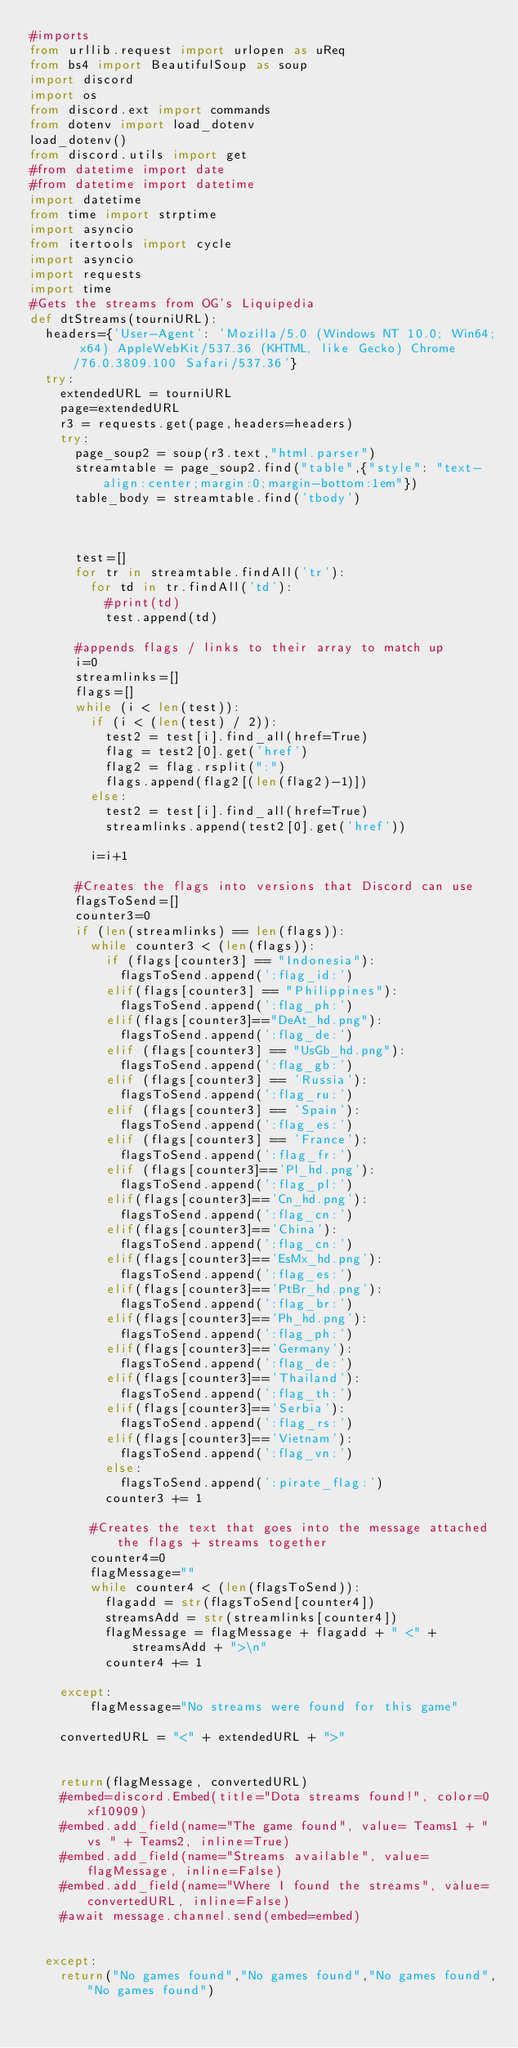<code> <loc_0><loc_0><loc_500><loc_500><_Python_>#imports
from urllib.request import urlopen as uReq
from bs4 import BeautifulSoup as soup
import discord
import os
from discord.ext import commands
from dotenv import load_dotenv
load_dotenv()
from discord.utils import get
#from datetime import date
#from datetime import datetime
import datetime
from time import strptime
import asyncio
from itertools import cycle
import asyncio
import requests
import time
#Gets the streams from OG's Liquipedia
def dtStreams(tourniURL):
  headers={'User-Agent': 'Mozilla/5.0 (Windows NT 10.0; Win64; x64) AppleWebKit/537.36 (KHTML, like Gecko) Chrome/76.0.3809.100 Safari/537.36'}
  try:
    extendedURL = tourniURL
    page=extendedURL
    r3 = requests.get(page,headers=headers)
    try:
      page_soup2 = soup(r3.text,"html.parser")
      streamtable = page_soup2.find("table",{"style": "text-align:center;margin:0;margin-bottom:1em"})
      table_body = streamtable.find('tbody')
      


      test=[]
      for tr in streamtable.findAll('tr'):
        for td in tr.findAll('td'):
          #print(td)
          test.append(td)
          
      #appends flags / links to their array to match up
      i=0
      streamlinks=[]
      flags=[]
      while (i < len(test)):
        if (i < (len(test) / 2)):
          test2 = test[i].find_all(href=True)
          flag = test2[0].get('href')
          flag2 = flag.rsplit(":")
          flags.append(flag2[(len(flag2)-1)])
        else:
          test2 = test[i].find_all(href=True)
          streamlinks.append(test2[0].get('href'))
        
        i=i+1
      
      #Creates the flags into versions that Discord can use
      flagsToSend=[]
      counter3=0
      if (len(streamlinks) == len(flags)):
        while counter3 < (len(flags)):
          if (flags[counter3] == "Indonesia"):
            flagsToSend.append(':flag_id:')
          elif(flags[counter3] == "Philippines"):
            flagsToSend.append(':flag_ph:')
          elif(flags[counter3]=="DeAt_hd.png"):
            flagsToSend.append(':flag_de:')
          elif (flags[counter3] == "UsGb_hd.png"):
            flagsToSend.append(':flag_gb:')
          elif (flags[counter3] == 'Russia'):
            flagsToSend.append(':flag_ru:')
          elif (flags[counter3] == 'Spain'):
            flagsToSend.append(':flag_es:')
          elif (flags[counter3] == 'France'):
            flagsToSend.append(':flag_fr:')
          elif (flags[counter3]=='Pl_hd.png'):
            flagsToSend.append(':flag_pl:')
          elif(flags[counter3]=='Cn_hd.png'):
            flagsToSend.append(':flag_cn:')
          elif(flags[counter3]=='China'):
            flagsToSend.append(':flag_cn:')
          elif(flags[counter3]=='EsMx_hd.png'):
            flagsToSend.append(':flag_es:')
          elif(flags[counter3]=='PtBr_hd.png'):
            flagsToSend.append(':flag_br:')
          elif(flags[counter3]=='Ph_hd.png'):
            flagsToSend.append(':flag_ph:')
          elif(flags[counter3]=='Germany'):
            flagsToSend.append(':flag_de:')
          elif(flags[counter3]=='Thailand'):
            flagsToSend.append(':flag_th:')
          elif(flags[counter3]=='Serbia'):
            flagsToSend.append(':flag_rs:')
          elif(flags[counter3]=='Vietnam'):
            flagsToSend.append(':flag_vn:')
          else:
            flagsToSend.append(':pirate_flag:')
          counter3 += 1

        #Creates the text that goes into the message attached the flags + streams together 
        counter4=0
        flagMessage=""
        while counter4 < (len(flagsToSend)):
          flagadd = str(flagsToSend[counter4])
          streamsAdd = str(streamlinks[counter4])
          flagMessage = flagMessage + flagadd + " <" + streamsAdd + ">\n"
          counter4 += 1  

    except:
        flagMessage="No streams were found for this game"
      
    convertedURL = "<" + extendedURL + ">"


    return(flagMessage, convertedURL)
    #embed=discord.Embed(title="Dota streams found!", color=0xf10909)
    #embed.add_field(name="The game found", value= Teams1 + " vs " + Teams2, inline=True)
    #embed.add_field(name="Streams available", value=flagMessage, inline=False)
    #embed.add_field(name="Where I found the streams", value= convertedURL, inline=False)
    #await message.channel.send(embed=embed)


  except:
    return("No games found","No games found","No games found","No games found")



</code> 